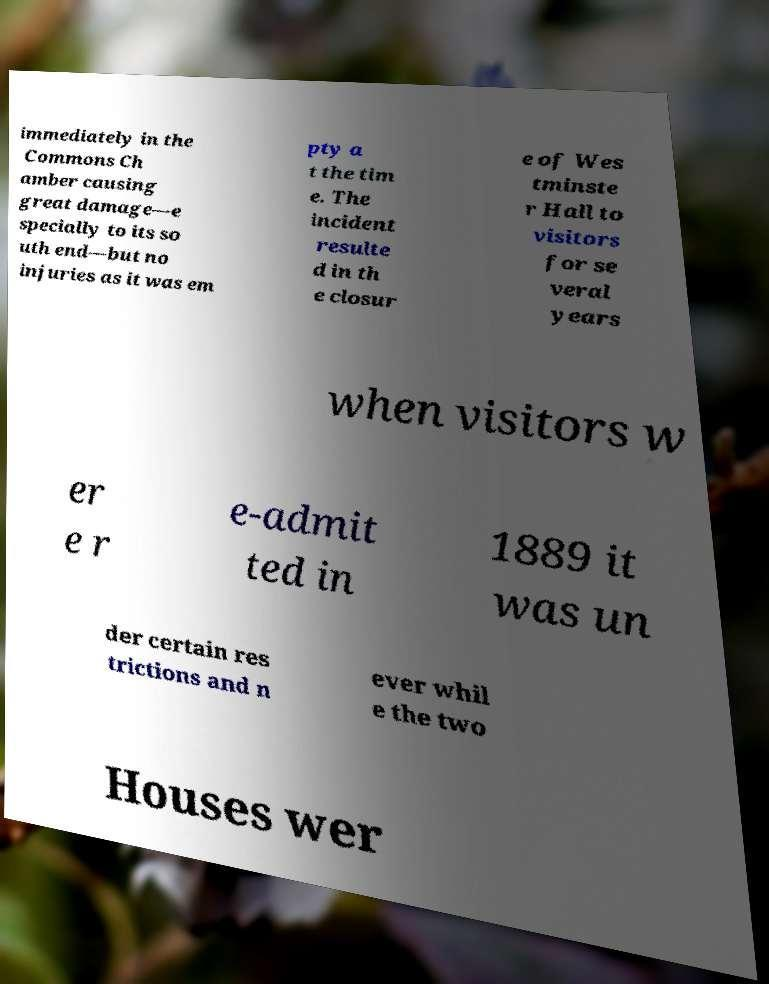There's text embedded in this image that I need extracted. Can you transcribe it verbatim? immediately in the Commons Ch amber causing great damage—e specially to its so uth end—but no injuries as it was em pty a t the tim e. The incident resulte d in th e closur e of Wes tminste r Hall to visitors for se veral years when visitors w er e r e-admit ted in 1889 it was un der certain res trictions and n ever whil e the two Houses wer 